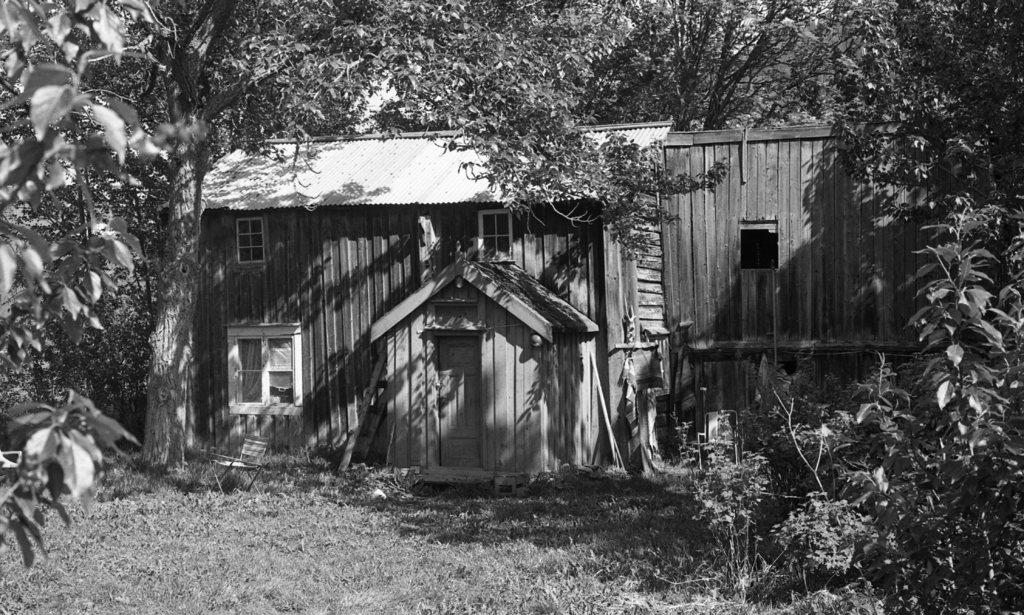What type of house is depicted in the image? The image contains a black and white picture of a wooden house. What features can be seen on the wooden house? The wooden house has windows. What type of vegetation is visible in the image? There is grass visible in the image. What other natural elements can be seen in the image? There are trees in the image. What type of pickle is hanging from the branches of the trees in the image? There are no pickles present in the image; it features a black and white picture of a wooden house with grass and trees. What government policy is being discussed in the image? There is no discussion or reference to any government policy in the image. 